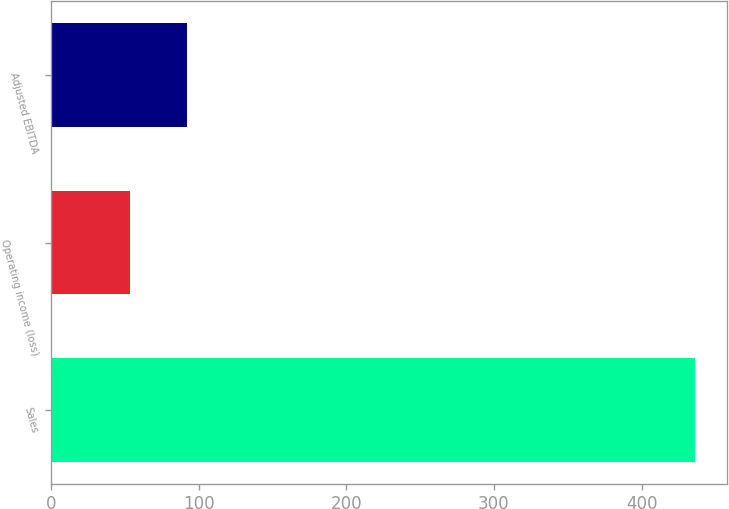Convert chart. <chart><loc_0><loc_0><loc_500><loc_500><bar_chart><fcel>Sales<fcel>Operating income (loss)<fcel>Adjusted EBITDA<nl><fcel>436.1<fcel>53.9<fcel>92.12<nl></chart> 